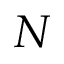<formula> <loc_0><loc_0><loc_500><loc_500>N</formula> 